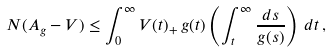<formula> <loc_0><loc_0><loc_500><loc_500>N ( A _ { g } - V ) \leq \int _ { 0 } ^ { \infty } V ( t ) _ { + } \, g ( t ) \left ( \int _ { t } ^ { \infty } \frac { d s } { g ( s ) } \right ) \, d t \, ,</formula> 